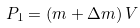<formula> <loc_0><loc_0><loc_500><loc_500>P _ { 1 } = \left ( { m + \Delta m } \right ) V</formula> 